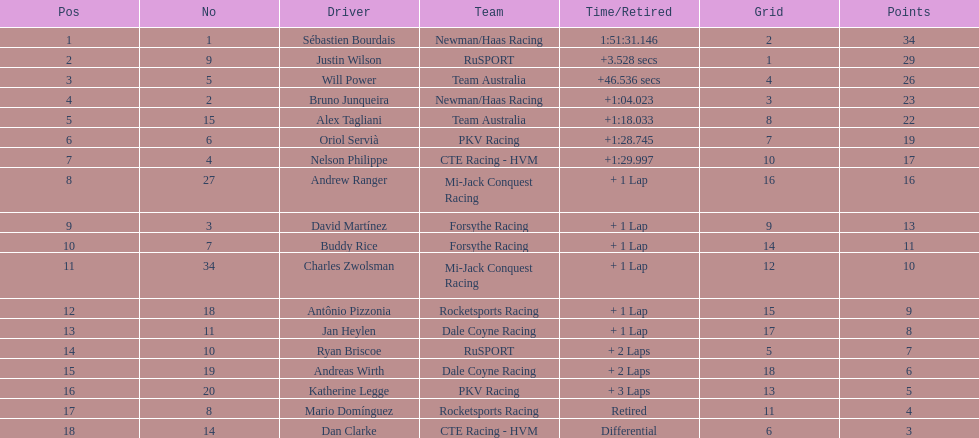At the 2006 gran premio telmex, how many drivers completed less than 60 laps? 2. Would you mind parsing the complete table? {'header': ['Pos', 'No', 'Driver', 'Team', 'Time/Retired', 'Grid', 'Points'], 'rows': [['1', '1', 'Sébastien Bourdais', 'Newman/Haas Racing', '1:51:31.146', '2', '34'], ['2', '9', 'Justin Wilson', 'RuSPORT', '+3.528 secs', '1', '29'], ['3', '5', 'Will Power', 'Team Australia', '+46.536 secs', '4', '26'], ['4', '2', 'Bruno Junqueira', 'Newman/Haas Racing', '+1:04.023', '3', '23'], ['5', '15', 'Alex Tagliani', 'Team Australia', '+1:18.033', '8', '22'], ['6', '6', 'Oriol Servià', 'PKV Racing', '+1:28.745', '7', '19'], ['7', '4', 'Nelson Philippe', 'CTE Racing - HVM', '+1:29.997', '10', '17'], ['8', '27', 'Andrew Ranger', 'Mi-Jack Conquest Racing', '+ 1 Lap', '16', '16'], ['9', '3', 'David Martínez', 'Forsythe Racing', '+ 1 Lap', '9', '13'], ['10', '7', 'Buddy Rice', 'Forsythe Racing', '+ 1 Lap', '14', '11'], ['11', '34', 'Charles Zwolsman', 'Mi-Jack Conquest Racing', '+ 1 Lap', '12', '10'], ['12', '18', 'Antônio Pizzonia', 'Rocketsports Racing', '+ 1 Lap', '15', '9'], ['13', '11', 'Jan Heylen', 'Dale Coyne Racing', '+ 1 Lap', '17', '8'], ['14', '10', 'Ryan Briscoe', 'RuSPORT', '+ 2 Laps', '5', '7'], ['15', '19', 'Andreas Wirth', 'Dale Coyne Racing', '+ 2 Laps', '18', '6'], ['16', '20', 'Katherine Legge', 'PKV Racing', '+ 3 Laps', '13', '5'], ['17', '8', 'Mario Domínguez', 'Rocketsports Racing', 'Retired', '11', '4'], ['18', '14', 'Dan Clarke', 'CTE Racing - HVM', 'Differential', '6', '3']]} 